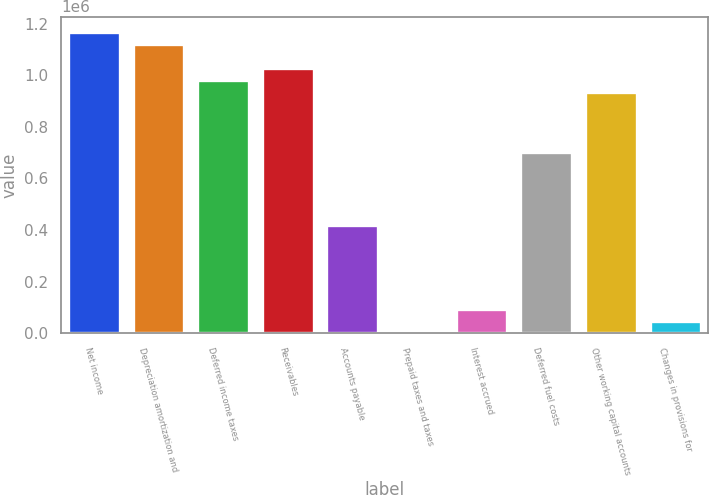Convert chart. <chart><loc_0><loc_0><loc_500><loc_500><bar_chart><fcel>Net income<fcel>Depreciation amortization and<fcel>Deferred income taxes<fcel>Receivables<fcel>Accounts payable<fcel>Prepaid taxes and taxes<fcel>Interest accrued<fcel>Deferred fuel costs<fcel>Other working capital accounts<fcel>Changes in provisions for<nl><fcel>1.16835e+06<fcel>1.12163e+06<fcel>981460<fcel>1.02818e+06<fcel>420797<fcel>300<fcel>93743.8<fcel>701128<fcel>934738<fcel>47021.9<nl></chart> 